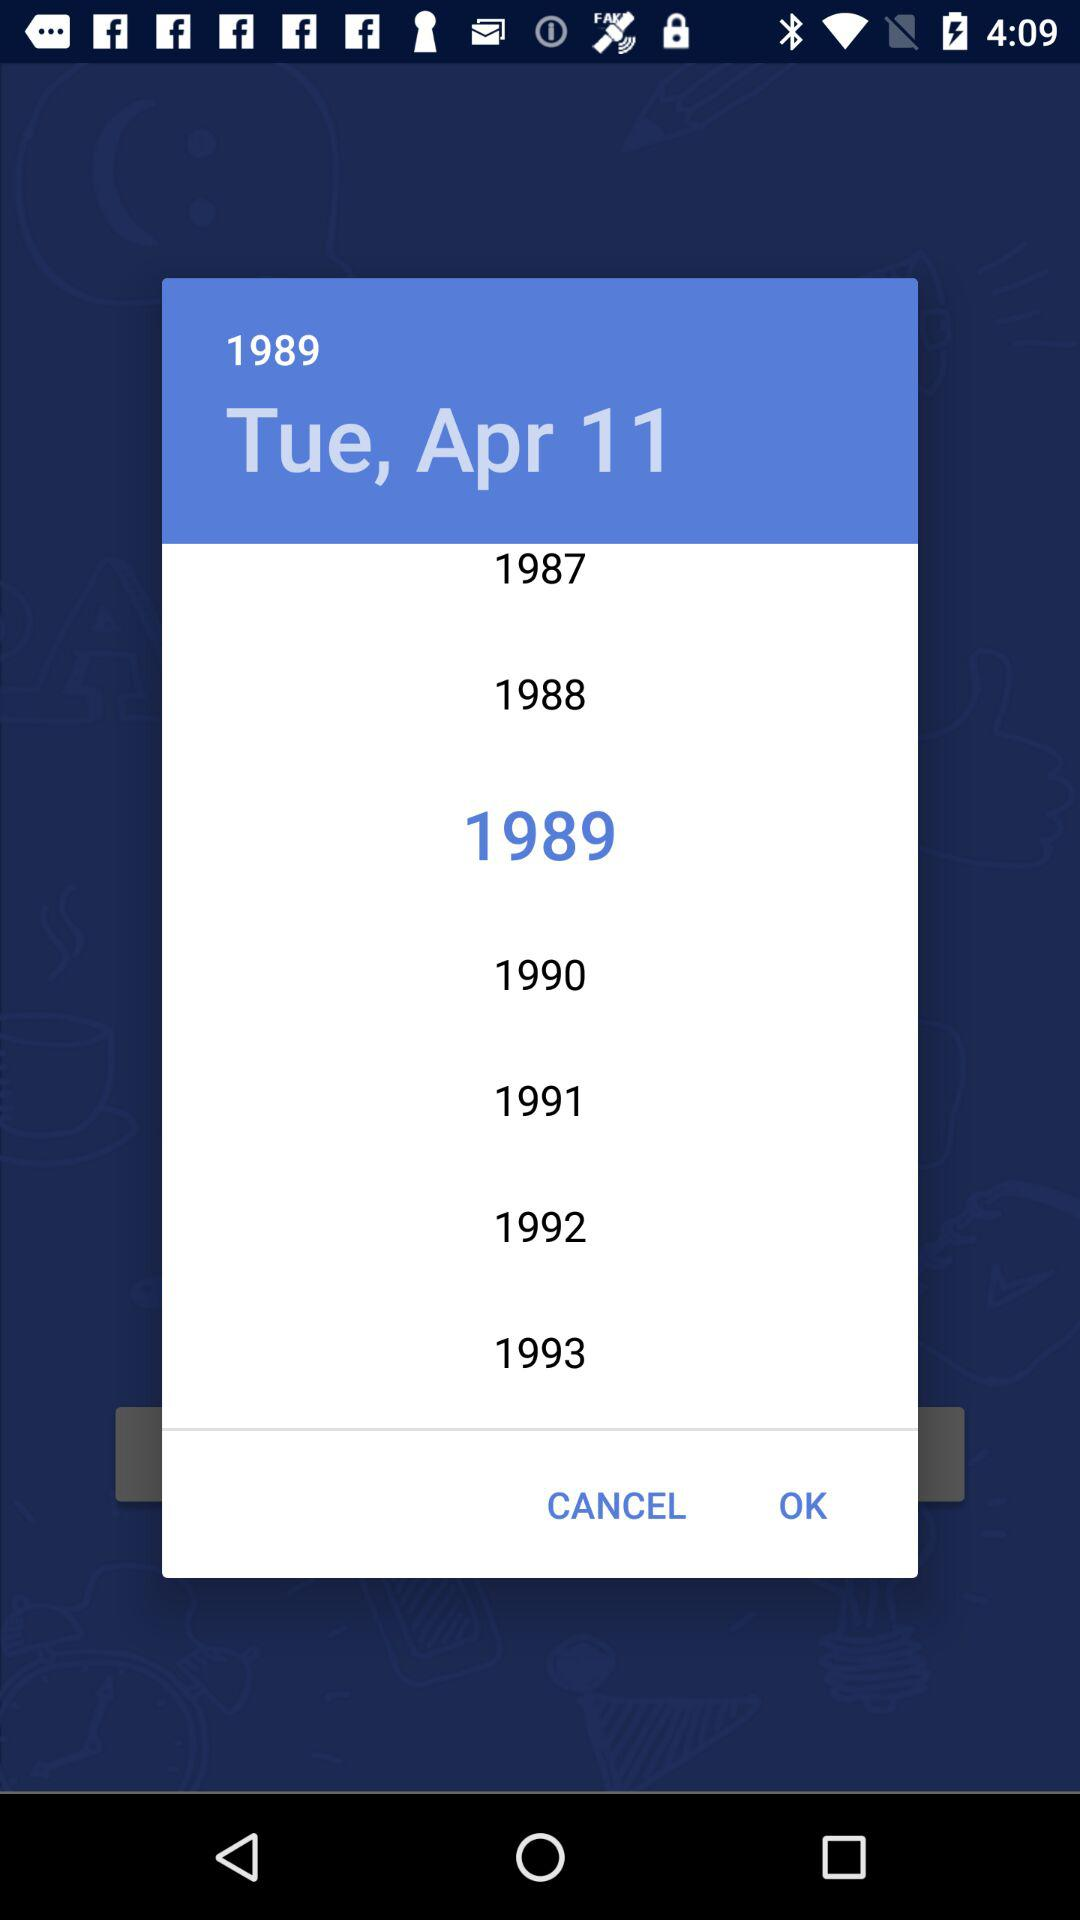What is the date? The date is Tuesday, April 11, 1989. 